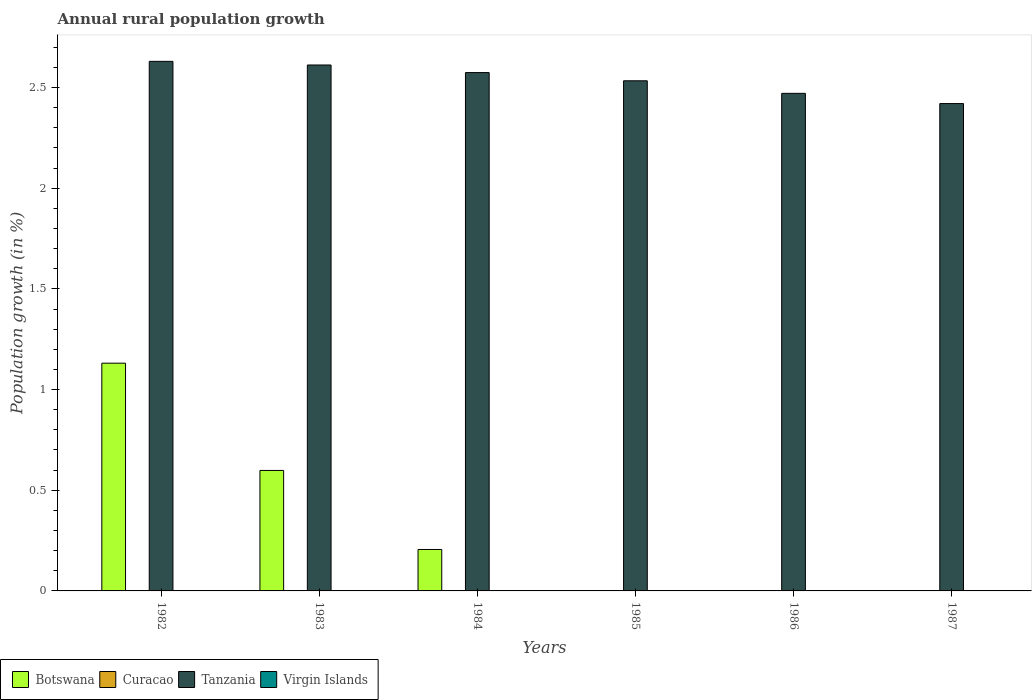How many different coloured bars are there?
Ensure brevity in your answer.  2. Are the number of bars on each tick of the X-axis equal?
Provide a short and direct response. No. How many bars are there on the 3rd tick from the right?
Your response must be concise. 1. What is the label of the 3rd group of bars from the left?
Provide a succinct answer. 1984. In how many cases, is the number of bars for a given year not equal to the number of legend labels?
Your response must be concise. 6. Across all years, what is the maximum percentage of rural population growth in Tanzania?
Your response must be concise. 2.63. What is the total percentage of rural population growth in Tanzania in the graph?
Your answer should be very brief. 15.24. What is the difference between the percentage of rural population growth in Botswana in 1982 and that in 1983?
Provide a succinct answer. 0.53. What is the difference between the percentage of rural population growth in Virgin Islands in 1986 and the percentage of rural population growth in Tanzania in 1984?
Make the answer very short. -2.57. What is the average percentage of rural population growth in Botswana per year?
Your answer should be very brief. 0.32. What is the ratio of the percentage of rural population growth in Tanzania in 1985 to that in 1987?
Provide a succinct answer. 1.05. Is the percentage of rural population growth in Tanzania in 1983 less than that in 1987?
Give a very brief answer. No. What is the difference between the highest and the second highest percentage of rural population growth in Botswana?
Your response must be concise. 0.53. What is the difference between the highest and the lowest percentage of rural population growth in Tanzania?
Make the answer very short. 0.21. In how many years, is the percentage of rural population growth in Curacao greater than the average percentage of rural population growth in Curacao taken over all years?
Your response must be concise. 0. Is the sum of the percentage of rural population growth in Botswana in 1982 and 1984 greater than the maximum percentage of rural population growth in Curacao across all years?
Give a very brief answer. Yes. Is it the case that in every year, the sum of the percentage of rural population growth in Tanzania and percentage of rural population growth in Virgin Islands is greater than the percentage of rural population growth in Botswana?
Give a very brief answer. Yes. Are all the bars in the graph horizontal?
Make the answer very short. No. What is the difference between two consecutive major ticks on the Y-axis?
Your answer should be very brief. 0.5. Where does the legend appear in the graph?
Offer a very short reply. Bottom left. How are the legend labels stacked?
Offer a very short reply. Horizontal. What is the title of the graph?
Your response must be concise. Annual rural population growth. Does "Australia" appear as one of the legend labels in the graph?
Your answer should be very brief. No. What is the label or title of the X-axis?
Offer a terse response. Years. What is the label or title of the Y-axis?
Ensure brevity in your answer.  Population growth (in %). What is the Population growth (in %) in Botswana in 1982?
Your response must be concise. 1.13. What is the Population growth (in %) of Curacao in 1982?
Your answer should be compact. 0. What is the Population growth (in %) in Tanzania in 1982?
Keep it short and to the point. 2.63. What is the Population growth (in %) in Botswana in 1983?
Offer a terse response. 0.6. What is the Population growth (in %) of Tanzania in 1983?
Provide a short and direct response. 2.61. What is the Population growth (in %) of Virgin Islands in 1983?
Your answer should be very brief. 0. What is the Population growth (in %) of Botswana in 1984?
Provide a succinct answer. 0.21. What is the Population growth (in %) in Curacao in 1984?
Offer a terse response. 0. What is the Population growth (in %) in Tanzania in 1984?
Make the answer very short. 2.57. What is the Population growth (in %) in Virgin Islands in 1984?
Provide a succinct answer. 0. What is the Population growth (in %) of Tanzania in 1985?
Your answer should be compact. 2.53. What is the Population growth (in %) of Curacao in 1986?
Your answer should be compact. 0. What is the Population growth (in %) of Tanzania in 1986?
Keep it short and to the point. 2.47. What is the Population growth (in %) of Tanzania in 1987?
Your response must be concise. 2.42. What is the Population growth (in %) of Virgin Islands in 1987?
Offer a very short reply. 0. Across all years, what is the maximum Population growth (in %) in Botswana?
Provide a short and direct response. 1.13. Across all years, what is the maximum Population growth (in %) of Tanzania?
Keep it short and to the point. 2.63. Across all years, what is the minimum Population growth (in %) in Botswana?
Your response must be concise. 0. Across all years, what is the minimum Population growth (in %) of Tanzania?
Keep it short and to the point. 2.42. What is the total Population growth (in %) of Botswana in the graph?
Keep it short and to the point. 1.94. What is the total Population growth (in %) of Curacao in the graph?
Your response must be concise. 0. What is the total Population growth (in %) of Tanzania in the graph?
Your response must be concise. 15.24. What is the difference between the Population growth (in %) in Botswana in 1982 and that in 1983?
Give a very brief answer. 0.53. What is the difference between the Population growth (in %) in Tanzania in 1982 and that in 1983?
Ensure brevity in your answer.  0.02. What is the difference between the Population growth (in %) in Botswana in 1982 and that in 1984?
Provide a short and direct response. 0.93. What is the difference between the Population growth (in %) in Tanzania in 1982 and that in 1984?
Give a very brief answer. 0.06. What is the difference between the Population growth (in %) in Tanzania in 1982 and that in 1985?
Offer a terse response. 0.1. What is the difference between the Population growth (in %) in Tanzania in 1982 and that in 1986?
Offer a terse response. 0.16. What is the difference between the Population growth (in %) in Tanzania in 1982 and that in 1987?
Offer a very short reply. 0.21. What is the difference between the Population growth (in %) of Botswana in 1983 and that in 1984?
Keep it short and to the point. 0.39. What is the difference between the Population growth (in %) in Tanzania in 1983 and that in 1984?
Your answer should be very brief. 0.04. What is the difference between the Population growth (in %) of Tanzania in 1983 and that in 1985?
Offer a very short reply. 0.08. What is the difference between the Population growth (in %) of Tanzania in 1983 and that in 1986?
Your answer should be very brief. 0.14. What is the difference between the Population growth (in %) in Tanzania in 1983 and that in 1987?
Provide a short and direct response. 0.19. What is the difference between the Population growth (in %) in Tanzania in 1984 and that in 1985?
Offer a terse response. 0.04. What is the difference between the Population growth (in %) in Tanzania in 1984 and that in 1986?
Provide a short and direct response. 0.1. What is the difference between the Population growth (in %) of Tanzania in 1984 and that in 1987?
Offer a terse response. 0.15. What is the difference between the Population growth (in %) of Tanzania in 1985 and that in 1986?
Give a very brief answer. 0.06. What is the difference between the Population growth (in %) of Tanzania in 1985 and that in 1987?
Keep it short and to the point. 0.11. What is the difference between the Population growth (in %) of Tanzania in 1986 and that in 1987?
Provide a succinct answer. 0.05. What is the difference between the Population growth (in %) in Botswana in 1982 and the Population growth (in %) in Tanzania in 1983?
Your answer should be compact. -1.48. What is the difference between the Population growth (in %) of Botswana in 1982 and the Population growth (in %) of Tanzania in 1984?
Ensure brevity in your answer.  -1.44. What is the difference between the Population growth (in %) in Botswana in 1982 and the Population growth (in %) in Tanzania in 1985?
Offer a very short reply. -1.4. What is the difference between the Population growth (in %) of Botswana in 1982 and the Population growth (in %) of Tanzania in 1986?
Your response must be concise. -1.34. What is the difference between the Population growth (in %) of Botswana in 1982 and the Population growth (in %) of Tanzania in 1987?
Provide a short and direct response. -1.29. What is the difference between the Population growth (in %) in Botswana in 1983 and the Population growth (in %) in Tanzania in 1984?
Your response must be concise. -1.98. What is the difference between the Population growth (in %) of Botswana in 1983 and the Population growth (in %) of Tanzania in 1985?
Your answer should be compact. -1.94. What is the difference between the Population growth (in %) of Botswana in 1983 and the Population growth (in %) of Tanzania in 1986?
Offer a terse response. -1.87. What is the difference between the Population growth (in %) of Botswana in 1983 and the Population growth (in %) of Tanzania in 1987?
Offer a terse response. -1.82. What is the difference between the Population growth (in %) of Botswana in 1984 and the Population growth (in %) of Tanzania in 1985?
Your answer should be compact. -2.33. What is the difference between the Population growth (in %) of Botswana in 1984 and the Population growth (in %) of Tanzania in 1986?
Provide a short and direct response. -2.27. What is the difference between the Population growth (in %) of Botswana in 1984 and the Population growth (in %) of Tanzania in 1987?
Your response must be concise. -2.21. What is the average Population growth (in %) in Botswana per year?
Keep it short and to the point. 0.32. What is the average Population growth (in %) of Curacao per year?
Keep it short and to the point. 0. What is the average Population growth (in %) of Tanzania per year?
Give a very brief answer. 2.54. In the year 1982, what is the difference between the Population growth (in %) of Botswana and Population growth (in %) of Tanzania?
Provide a short and direct response. -1.5. In the year 1983, what is the difference between the Population growth (in %) of Botswana and Population growth (in %) of Tanzania?
Your answer should be very brief. -2.01. In the year 1984, what is the difference between the Population growth (in %) of Botswana and Population growth (in %) of Tanzania?
Ensure brevity in your answer.  -2.37. What is the ratio of the Population growth (in %) in Botswana in 1982 to that in 1983?
Your answer should be very brief. 1.89. What is the ratio of the Population growth (in %) of Botswana in 1982 to that in 1984?
Offer a terse response. 5.49. What is the ratio of the Population growth (in %) in Tanzania in 1982 to that in 1984?
Offer a very short reply. 1.02. What is the ratio of the Population growth (in %) in Tanzania in 1982 to that in 1985?
Ensure brevity in your answer.  1.04. What is the ratio of the Population growth (in %) of Tanzania in 1982 to that in 1986?
Give a very brief answer. 1.06. What is the ratio of the Population growth (in %) in Tanzania in 1982 to that in 1987?
Offer a very short reply. 1.09. What is the ratio of the Population growth (in %) in Botswana in 1983 to that in 1984?
Your answer should be compact. 2.91. What is the ratio of the Population growth (in %) in Tanzania in 1983 to that in 1984?
Your response must be concise. 1.01. What is the ratio of the Population growth (in %) in Tanzania in 1983 to that in 1985?
Your response must be concise. 1.03. What is the ratio of the Population growth (in %) in Tanzania in 1983 to that in 1986?
Ensure brevity in your answer.  1.06. What is the ratio of the Population growth (in %) in Tanzania in 1983 to that in 1987?
Keep it short and to the point. 1.08. What is the ratio of the Population growth (in %) in Tanzania in 1984 to that in 1985?
Offer a terse response. 1.02. What is the ratio of the Population growth (in %) of Tanzania in 1984 to that in 1986?
Your answer should be compact. 1.04. What is the ratio of the Population growth (in %) of Tanzania in 1984 to that in 1987?
Provide a short and direct response. 1.06. What is the ratio of the Population growth (in %) of Tanzania in 1985 to that in 1986?
Your answer should be compact. 1.03. What is the ratio of the Population growth (in %) of Tanzania in 1985 to that in 1987?
Your answer should be compact. 1.05. What is the difference between the highest and the second highest Population growth (in %) in Botswana?
Your answer should be compact. 0.53. What is the difference between the highest and the second highest Population growth (in %) in Tanzania?
Ensure brevity in your answer.  0.02. What is the difference between the highest and the lowest Population growth (in %) of Botswana?
Provide a short and direct response. 1.13. What is the difference between the highest and the lowest Population growth (in %) of Tanzania?
Your answer should be compact. 0.21. 